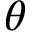<formula> <loc_0><loc_0><loc_500><loc_500>\theta</formula> 